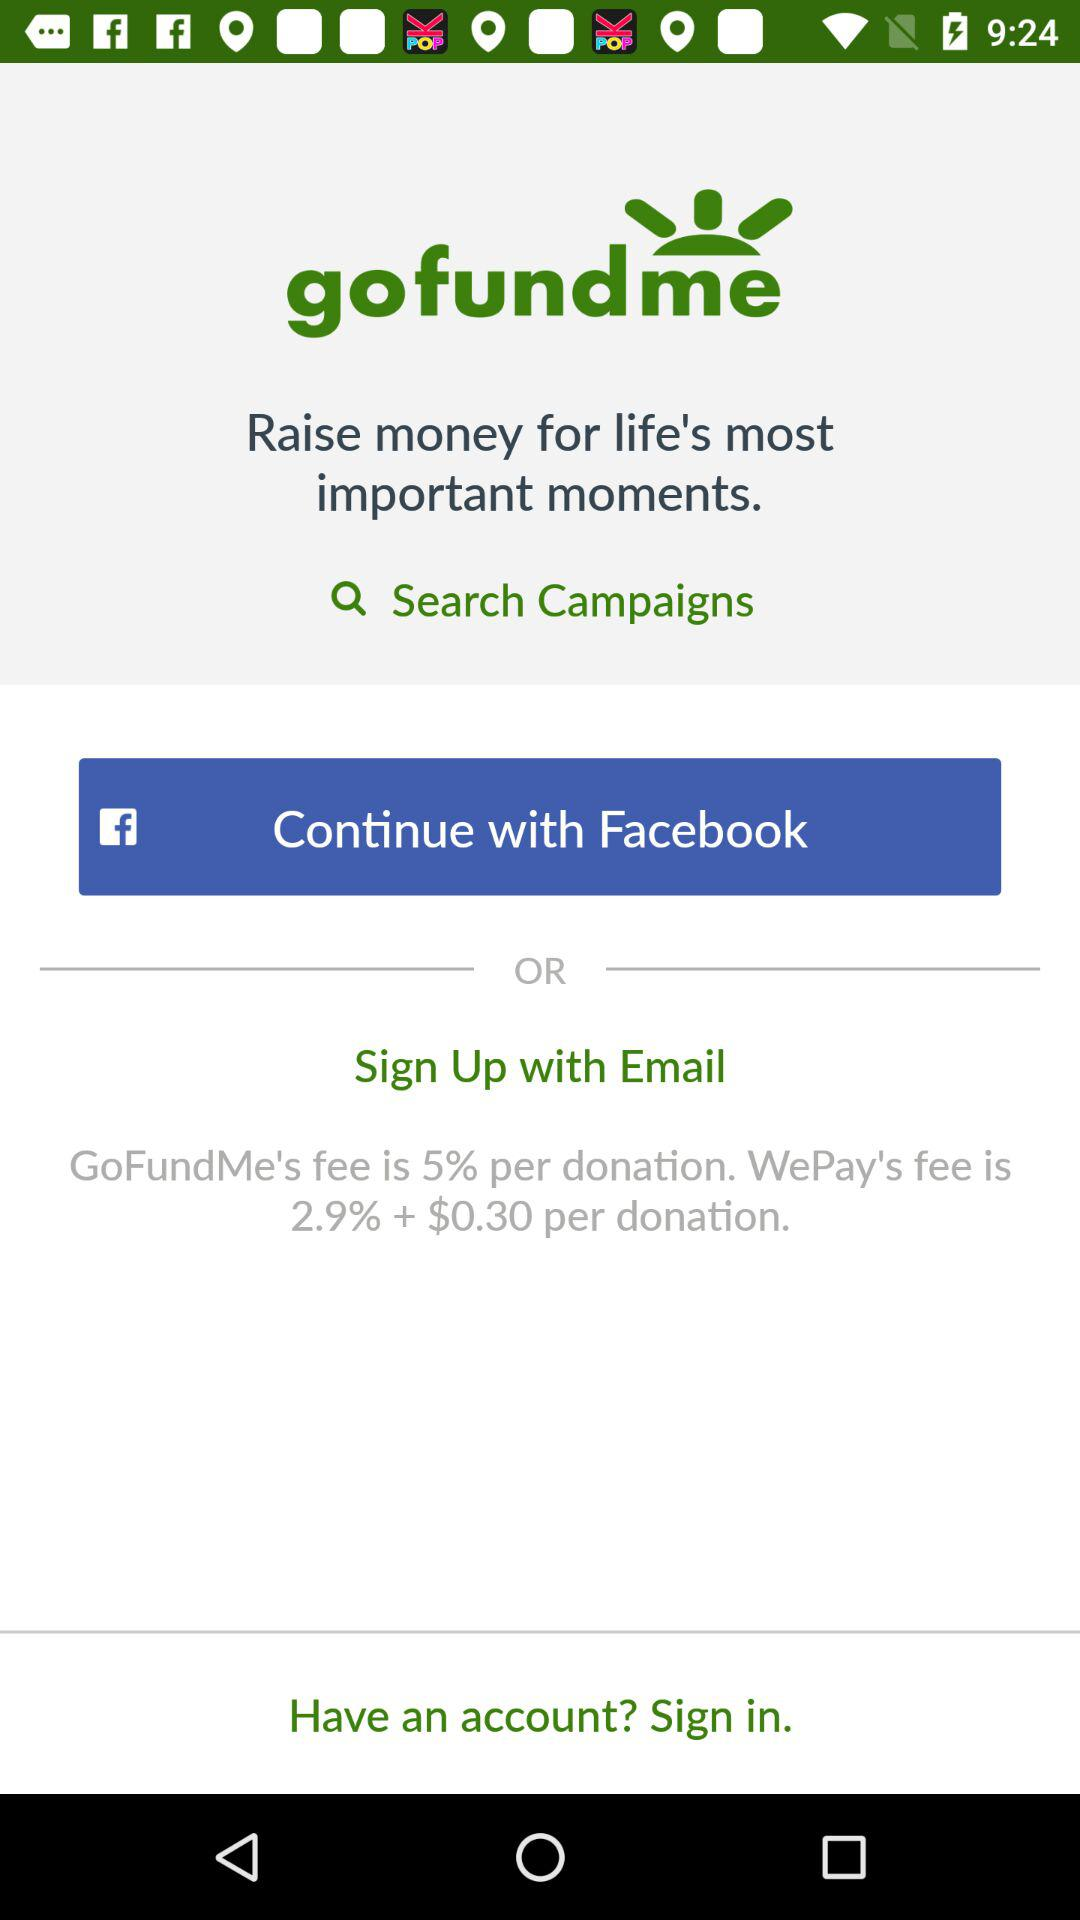How much is GoFundMe's fee per donation?
Answer the question using a single word or phrase. 5% 